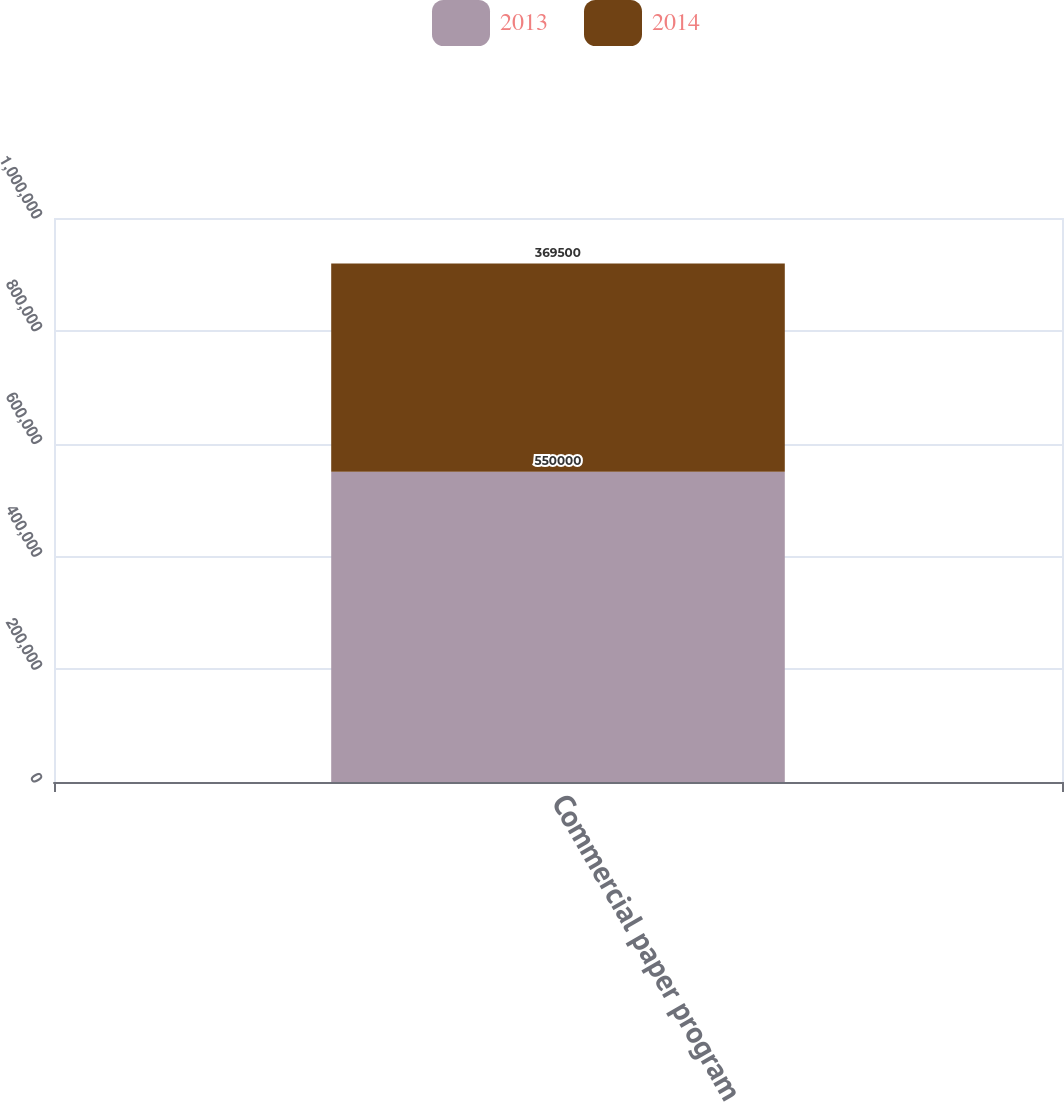<chart> <loc_0><loc_0><loc_500><loc_500><stacked_bar_chart><ecel><fcel>Commercial paper program<nl><fcel>2013<fcel>550000<nl><fcel>2014<fcel>369500<nl></chart> 